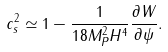<formula> <loc_0><loc_0><loc_500><loc_500>c _ { s } ^ { 2 } \simeq 1 - \frac { 1 } { 1 8 M _ { P } ^ { 2 } H ^ { 4 } } \frac { \partial W } { \partial \psi } .</formula> 